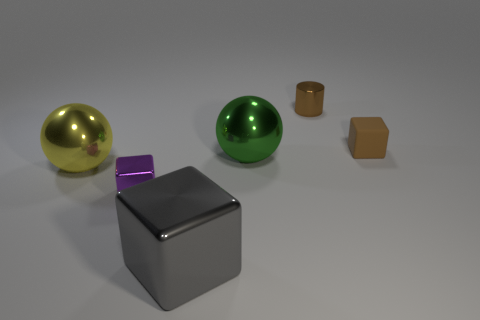Add 3 tiny cyan metal balls. How many objects exist? 9 Subtract all gray blocks. How many blocks are left? 2 Subtract all brown blocks. How many blocks are left? 2 Subtract all balls. How many objects are left? 4 Subtract 2 cubes. How many cubes are left? 1 Subtract all small brown shiny cylinders. Subtract all yellow cubes. How many objects are left? 5 Add 1 big green spheres. How many big green spheres are left? 2 Add 2 gray metallic objects. How many gray metallic objects exist? 3 Subtract 0 blue cylinders. How many objects are left? 6 Subtract all brown blocks. Subtract all purple cylinders. How many blocks are left? 2 